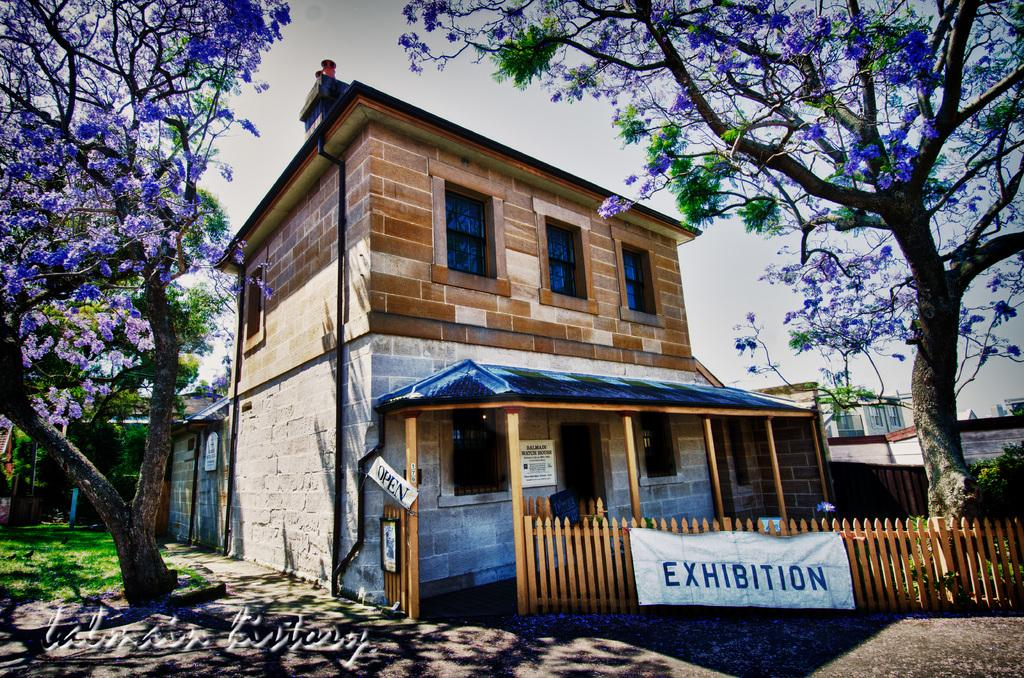What type of structures can be seen in the image? There are buildings in the image. What type of vegetation is present in the image? There are trees in the image. What type of ground surface is visible at the bottom of the image? There is grass on the surface at the bottom of the image. What type of vacation is the father planning in the image? There is no reference to a vacation or a father in the image, so it's not possible to answer that question. 